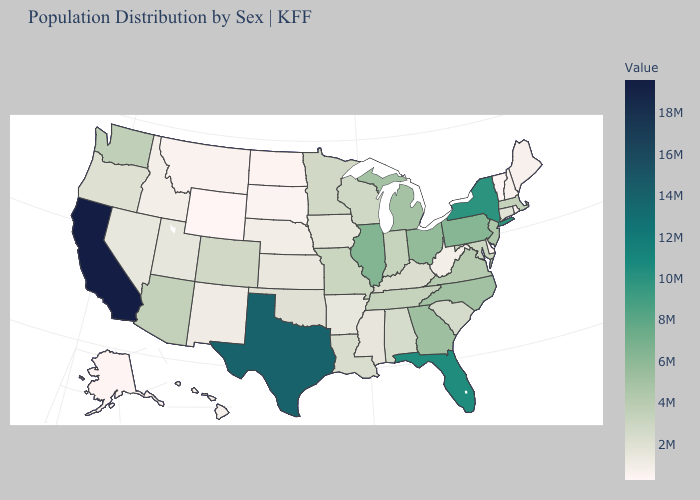Which states have the lowest value in the West?
Keep it brief. Wyoming. Among the states that border Louisiana , which have the lowest value?
Short answer required. Arkansas. Does Arizona have a lower value than Illinois?
Write a very short answer. Yes. Does Kansas have the lowest value in the MidWest?
Short answer required. No. Which states have the highest value in the USA?
Keep it brief. California. Among the states that border Arizona , does Colorado have the lowest value?
Quick response, please. No. Does Indiana have the highest value in the MidWest?
Answer briefly. No. Does Florida have the highest value in the South?
Short answer required. No. 